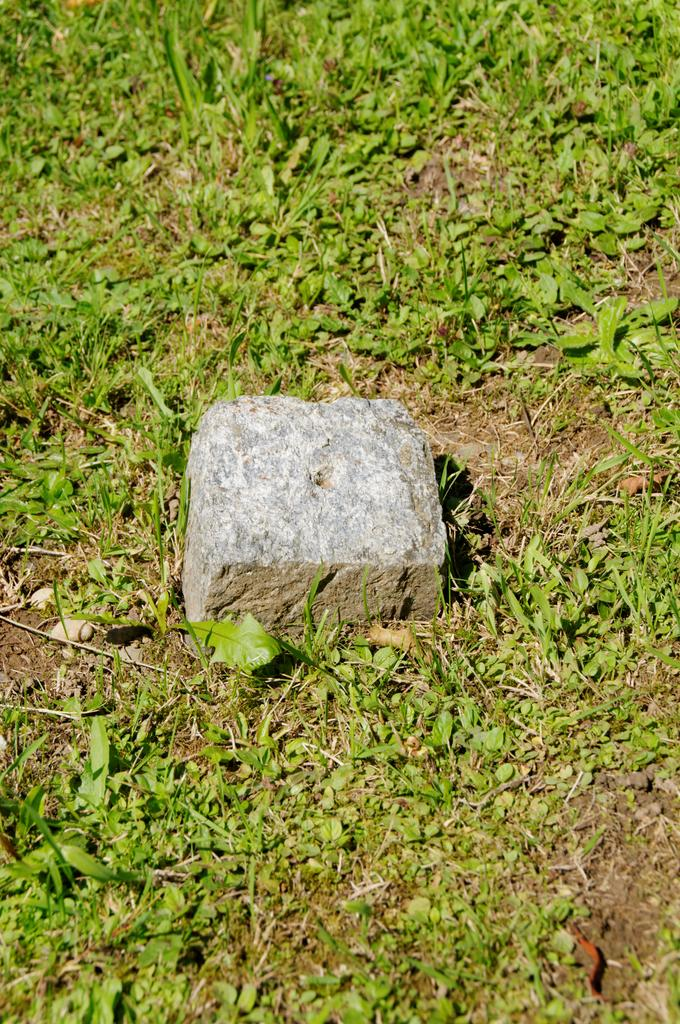What type of path can be seen in the image? There is a grass path in the image. What other natural elements are present in the image? There are plant saplings in the image. What is the shape of the rock in the image? The rock has a cube shape. What colors can be observed on the rock in the image? The rock is white in color, with some parts being gray. Can you tell me how many mittens are being worn by the plant saplings in the image? There are no mittens present in the image, as it features a grass path, plant saplings, and a rock. What type of fictional character can be seen interacting with the rock in the image? There are no fictional characters present in the image; it only features a grass path, plant saplings, and a rock. 